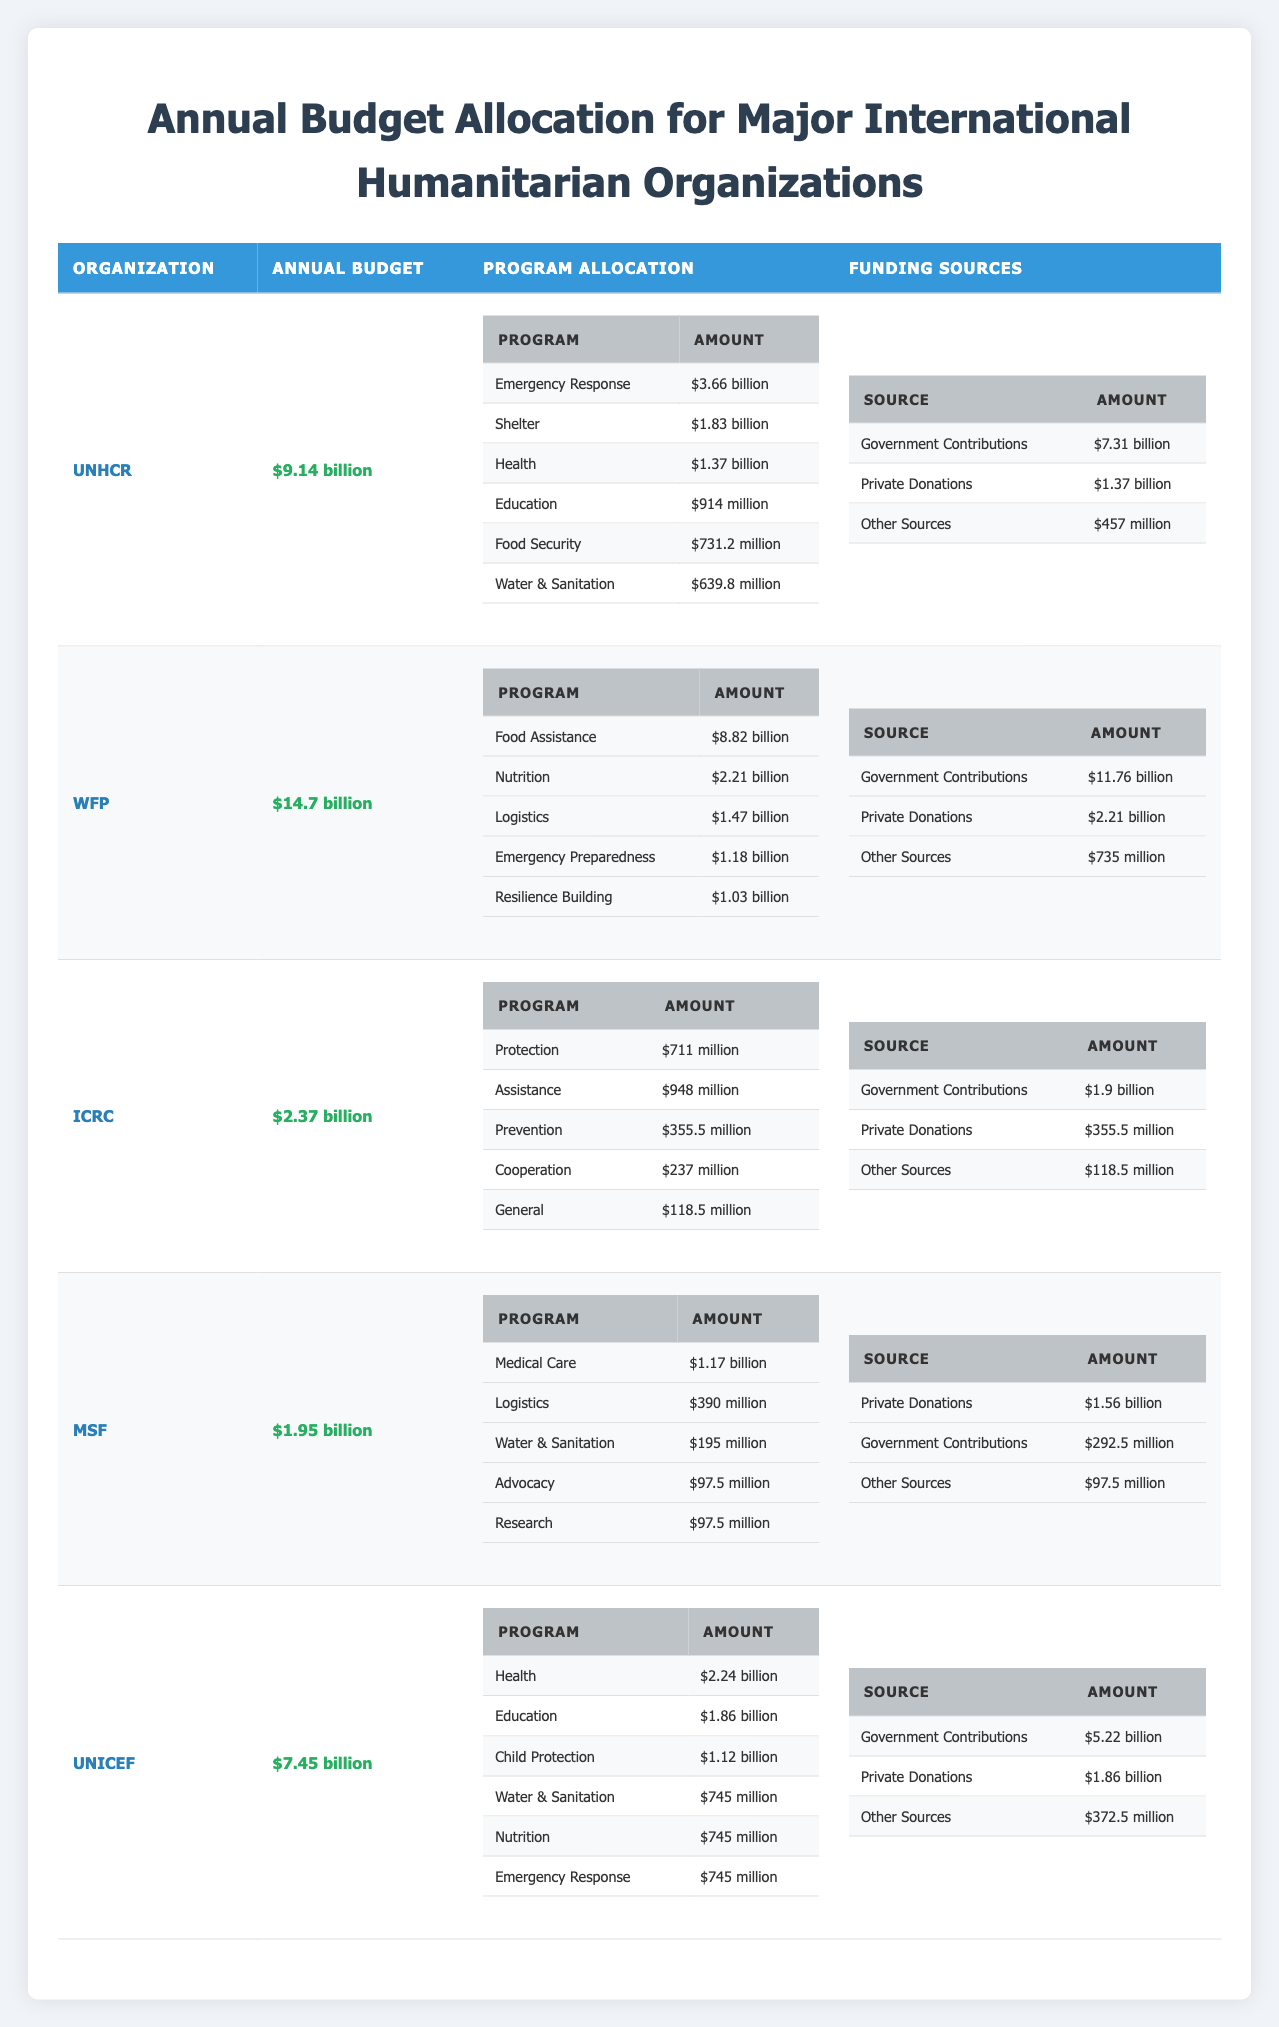What is the annual budget of the United Nations High Commissioner for Refugees (UNHCR)? The annual budget for UNHCR is stated directly in the table as $9.14 billion.
Answer: $9.14 billion What percentage of the World Food Programme's budget is allocated to food assistance? The annual budget of WFP is $14.7 billion, and the food assistance allocation is $8.82 billion. To find the percentage, calculate (8.82 / 14.7) * 100 = 59.9%.
Answer: 59.9% Is the funding from private donations for UNICEF greater than the total budget of Médecins Sans Frontières (MSF)? UNICEF's private donations are $1.86 billion while MSF's total budget is $1.95 billion. Since $1.86 billion is less than $1.95 billion, the statement is false.
Answer: No Which organization has the highest funding from government contributions? By comparing the government contributions across organizations, WFP has $11.76 billion, which is higher than all others listed, making it the highest.
Answer: World Food Programme (WFP) What is the total program allocation for health-related programs across all organizations? The health program allocations are as follows: UNHCR - $1.37 billion, WFP - $2.21 billion, ICRC - $0.711 billion, MSF - $1.17 billion, and UNICEF - $2.24 billion. Adding these gives $1.37 + $2.21 + $0.711 + $1.17 + $2.24 = $7.72 billion.
Answer: $7.72 billion Does the International Committee of the Red Cross (ICRC) receive more funding from private donations than the United Nations High Commissioner for Refugees (UNHCR)? ICRC's private donations total $355.5 million, while UNHCR's private donations are $1.37 billion. Since $355.5 million is much less than $1.37 billion, the statement is false.
Answer: No What is the total budget for emergency response across all organizations? The emergency response budgets are: UNHCR - $3.66 billion, WFP - $1.18 billion, ICRC - not specified in this category, MSF - not specified, UNICEF - $0.745 billion. The total is $3.66 + $1.18 + $0.745 = $5.585 billion.
Answer: $5.585 billion Which organization allocates the least amount to logistics in their budget? MSF allocates $390 million to logistics while other organizations allocate more: WFP - $1.47 billion, ICRC - not specified but at least $237 million, and UNHCR doesn't specify logistics. Therefore, MSF has the least allocation for logistics.
Answer: Médecins Sans Frontières (MSF) What fraction of the total budget of UNICEF is allocated to health programs? UNICEF's budget is $7.45 billion, with health program allocation at $2.24 billion. The fraction is 2.24 / 7.45 which simplifies to approximately 0.301 or 30.1%.
Answer: 30.1% 